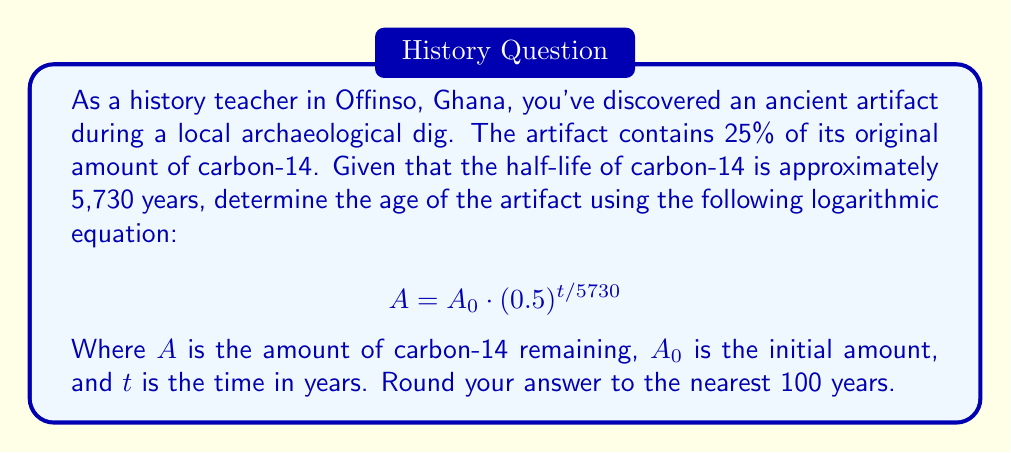Can you answer this question? Let's approach this step-by-step:

1) We know that 25% of the original carbon-14 remains. This means $A = 0.25A_0$.

2) Substituting this into our equation:

   $$ 0.25A_0 = A_0 \cdot (0.5)^{t/5730} $$

3) Simplify by dividing both sides by $A_0$:

   $$ 0.25 = (0.5)^{t/5730} $$

4) Take the natural log of both sides:

   $$ \ln(0.25) = \ln((0.5)^{t/5730}) $$

5) Use the logarithm property $\ln(x^n) = n\ln(x)$:

   $$ \ln(0.25) = \frac{t}{5730} \ln(0.5) $$

6) Solve for $t$:

   $$ t = 5730 \cdot \frac{\ln(0.25)}{\ln(0.5)} $$

7) Calculate:
   
   $$ t = 5730 \cdot \frac{-1.3862943611}{-0.6931471806} \approx 11460.9 $$

8) Rounding to the nearest 100 years:

   $t \approx 11,500$ years
Answer: The artifact is approximately 11,500 years old. 